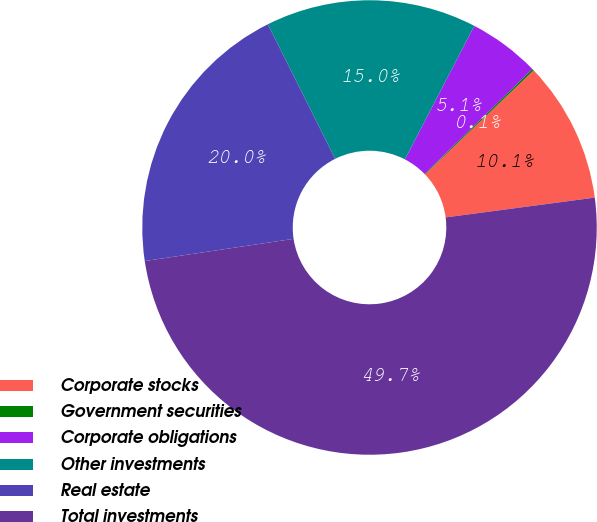Convert chart to OTSL. <chart><loc_0><loc_0><loc_500><loc_500><pie_chart><fcel>Corporate stocks<fcel>Government securities<fcel>Corporate obligations<fcel>Other investments<fcel>Real estate<fcel>Total investments<nl><fcel>10.05%<fcel>0.13%<fcel>5.09%<fcel>15.01%<fcel>19.97%<fcel>49.73%<nl></chart> 